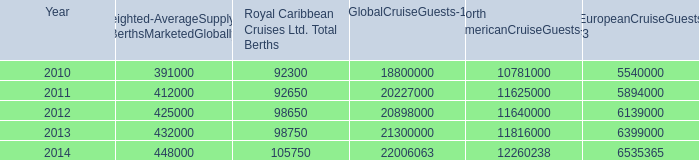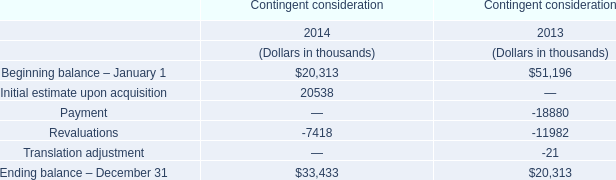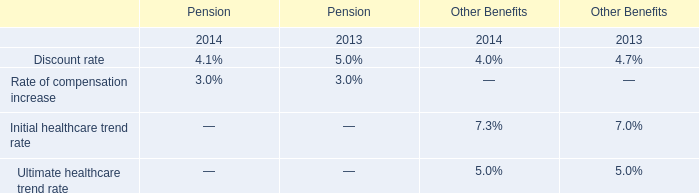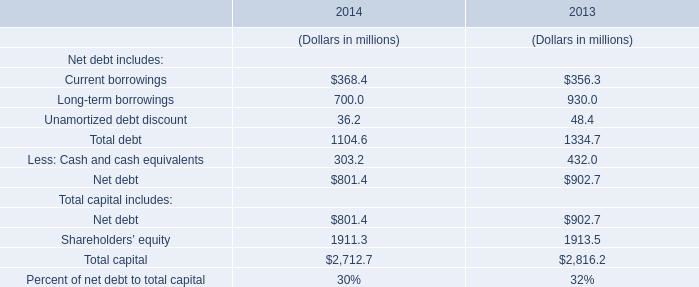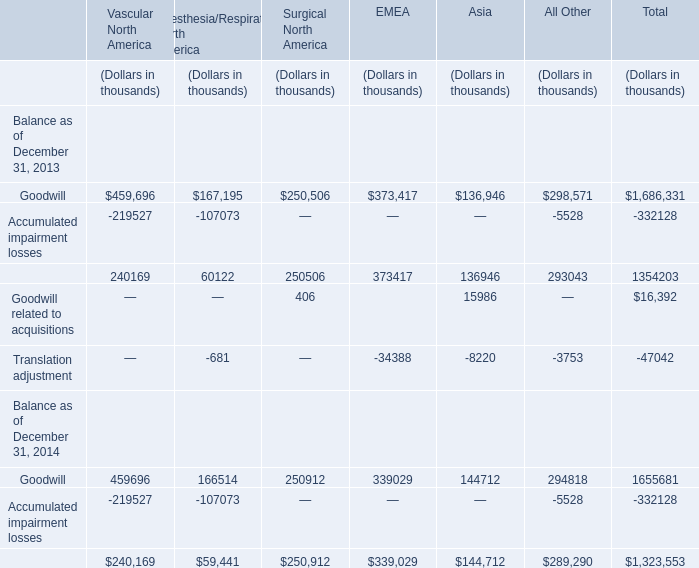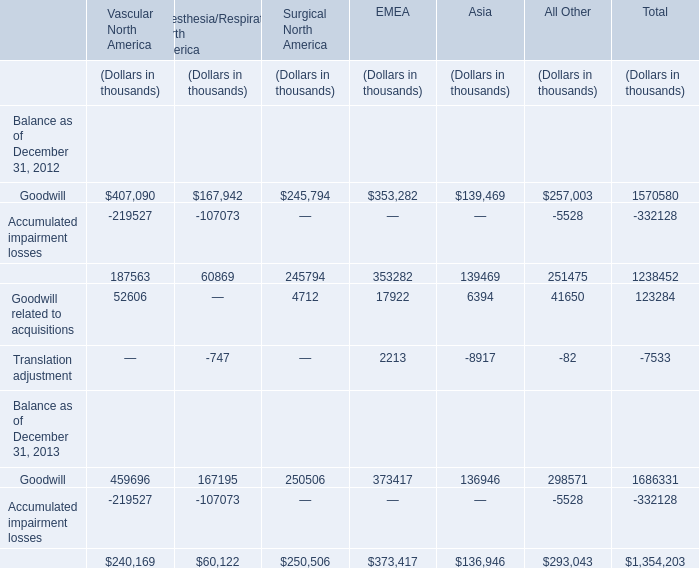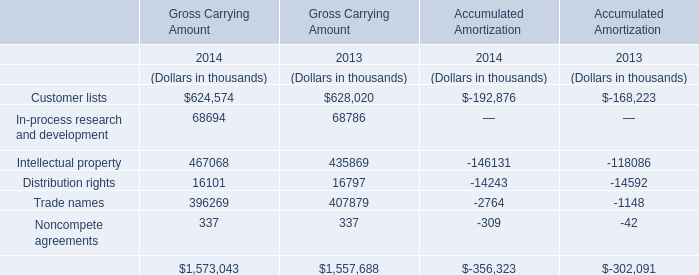What's the increasing rate of Distribution rights for Gross Carrying Amount in 2014? 
Computations: ((16101 - 16797) / 16797)
Answer: -0.04144. 